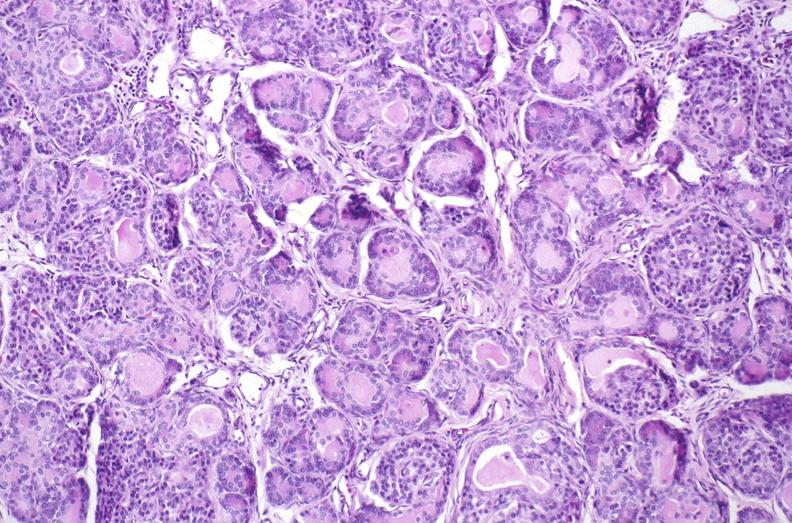what is present?
Answer the question using a single word or phrase. Pancreas 